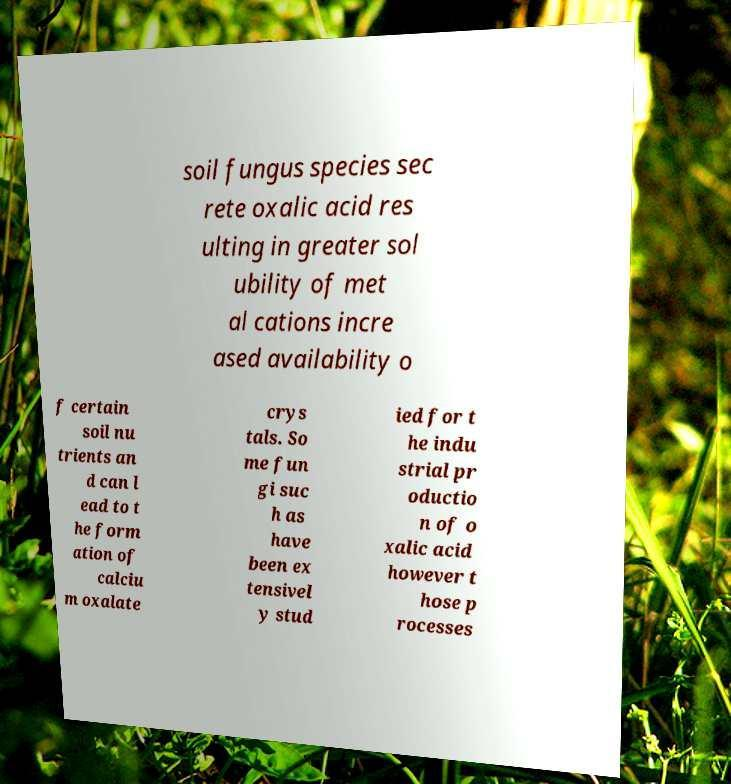Can you read and provide the text displayed in the image?This photo seems to have some interesting text. Can you extract and type it out for me? soil fungus species sec rete oxalic acid res ulting in greater sol ubility of met al cations incre ased availability o f certain soil nu trients an d can l ead to t he form ation of calciu m oxalate crys tals. So me fun gi suc h as have been ex tensivel y stud ied for t he indu strial pr oductio n of o xalic acid however t hose p rocesses 